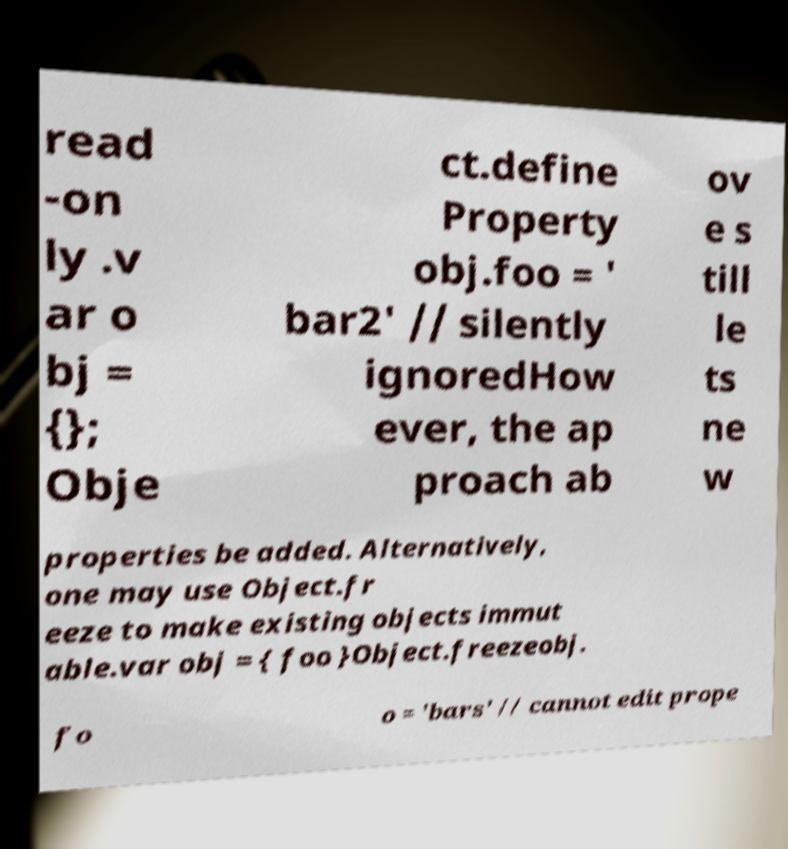Please read and relay the text visible in this image. What does it say? read -on ly .v ar o bj = {}; Obje ct.define Property obj.foo = ' bar2' // silently ignoredHow ever, the ap proach ab ov e s till le ts ne w properties be added. Alternatively, one may use Object.fr eeze to make existing objects immut able.var obj = { foo }Object.freezeobj. fo o = 'bars' // cannot edit prope 